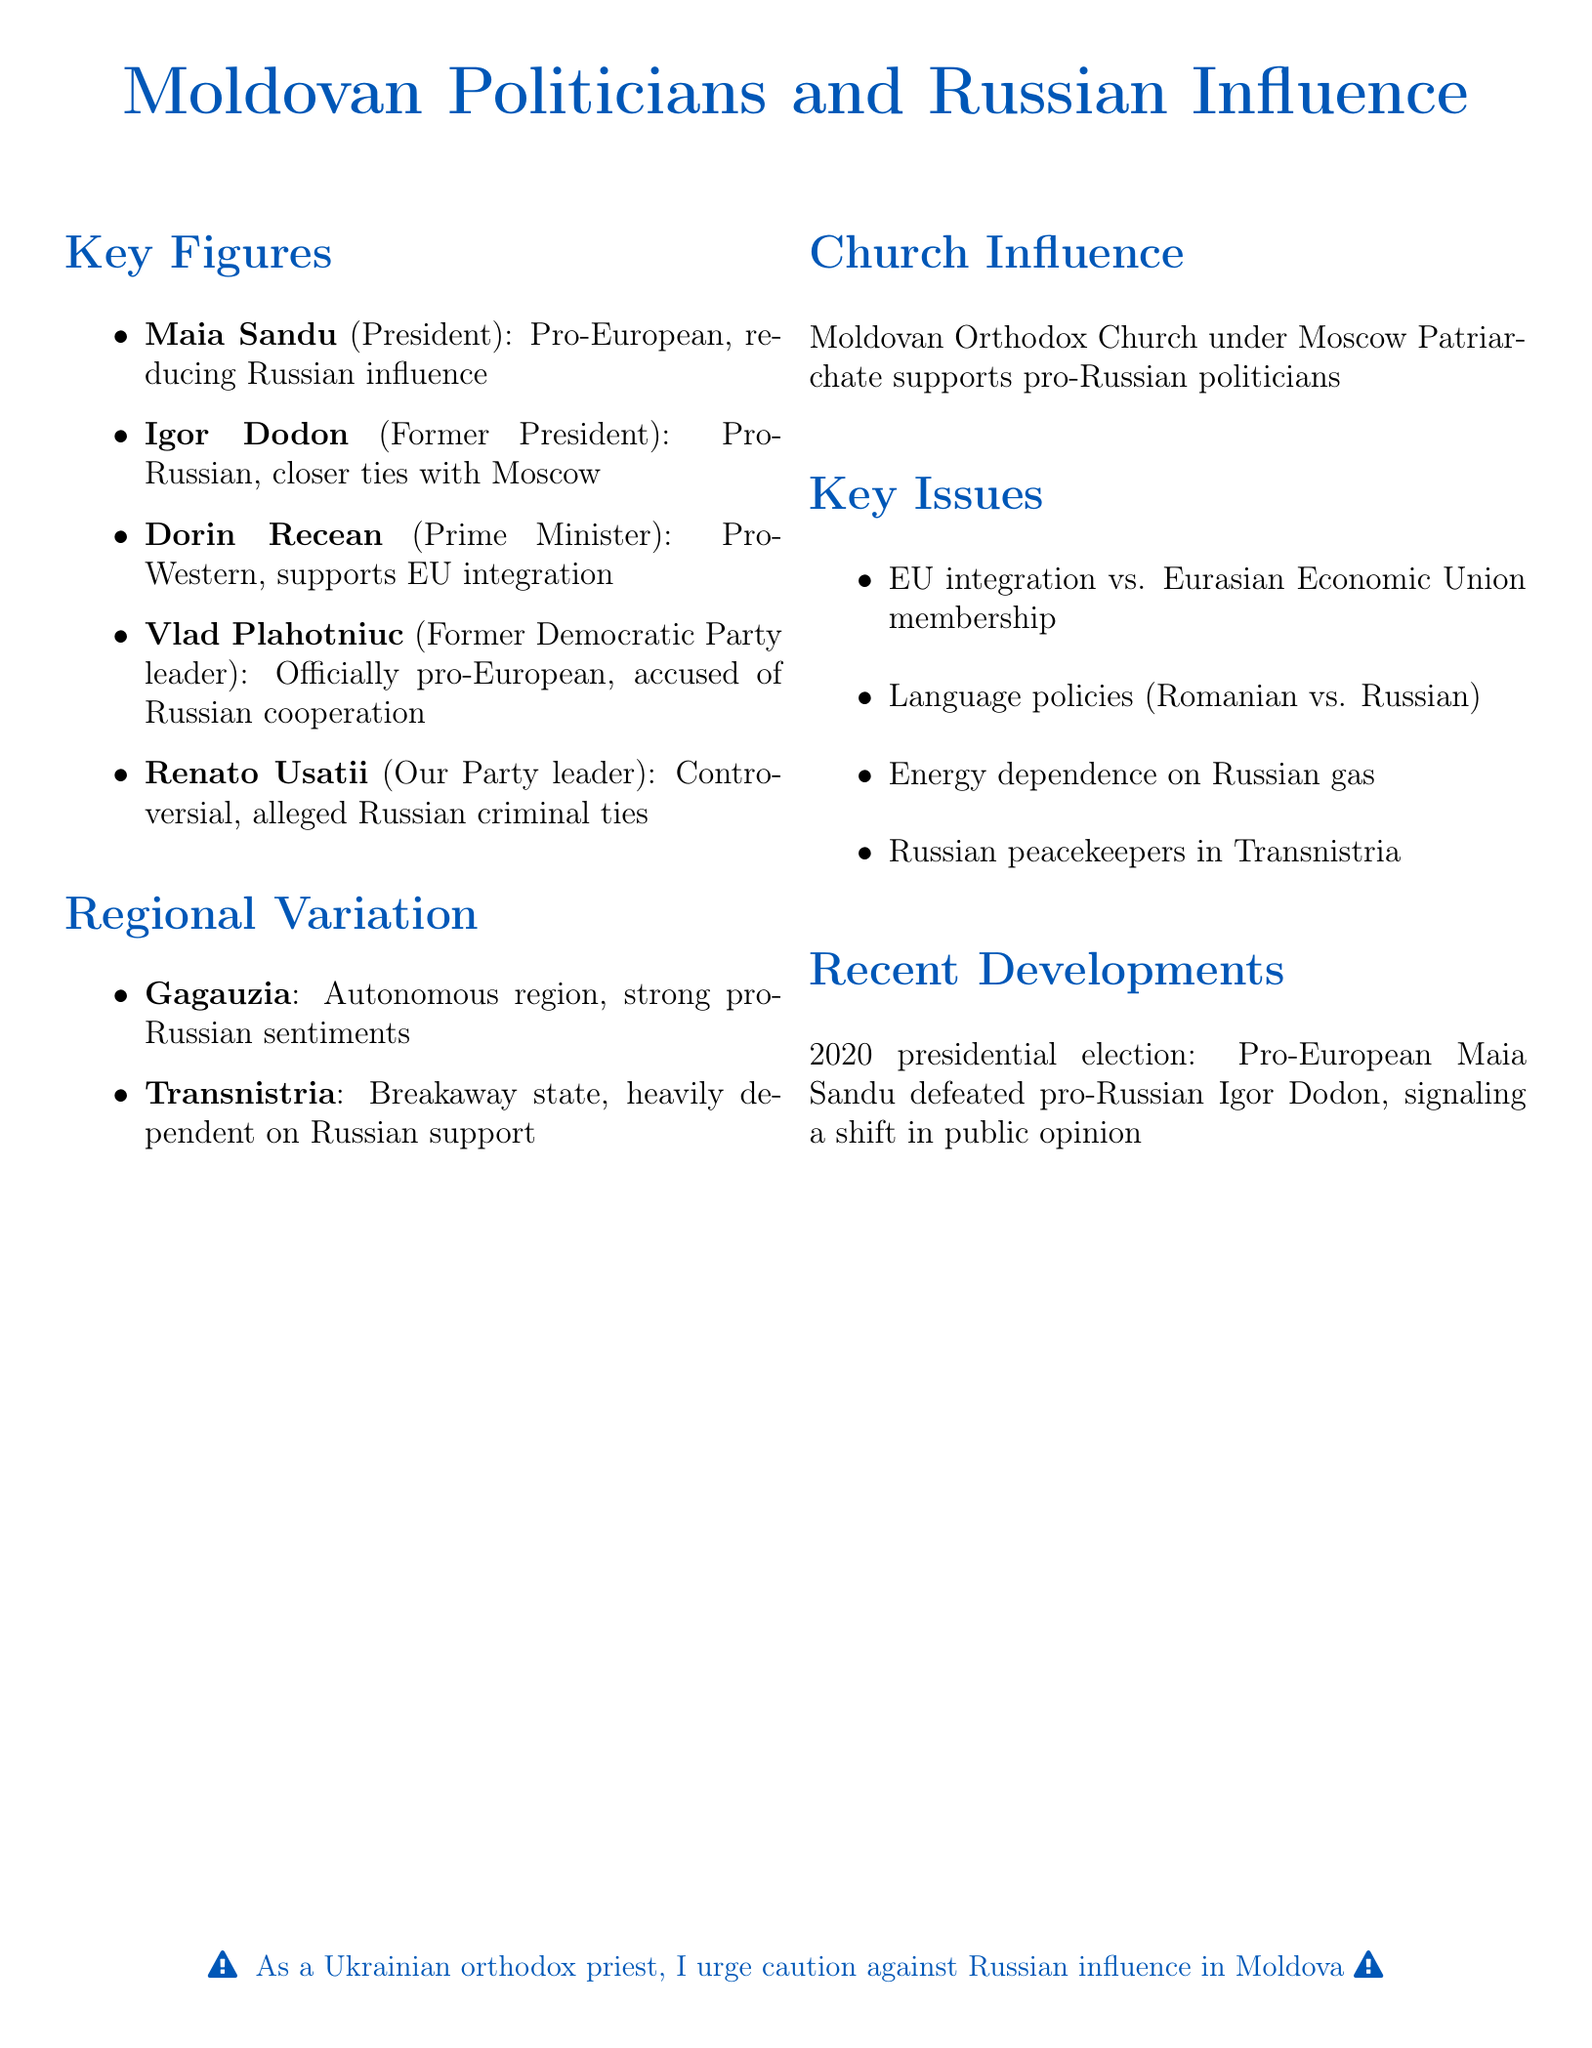What is the position of Maia Sandu? Maia Sandu is mentioned as the President of Moldova in the document.
Answer: President of Moldova What stance does Igor Dodon have? Igor Dodon is identified as pro-Russian and advocates for closer ties with Moscow.
Answer: Pro-Russian What is the key issue regarding energy? The key issue related to energy is about reliance on Russian gas.
Answer: Energy dependence on Russian gas Which region in Moldova has strong pro-Russian sentiments? The document states that Gagauzia is an autonomous region with strong pro-Russian sentiments.
Answer: Gagauzia What significant event occurred in the 2020 presidential election? The document highlights that in the 2020 presidential election, Maia Sandu defeated Igor Dodon, signaling a shift in public opinion.
Answer: Maia Sandu defeated Igor Dodon What is the official church influence in Moldova? The Moldovan Orthodox Church under Moscow Patriarchate supports pro-Russian politicians, according to the document.
Answer: Supports pro-Russian politicians What does Dorin Recean support? Dorin Recean is noted for supporting EU integration in his stance.
Answer: EU integration Who is accused of having ties to Russian criminal groups? Renato Usatii is described as a controversial figure accused of having ties to Russian criminal groups.
Answer: Renato Usatii 